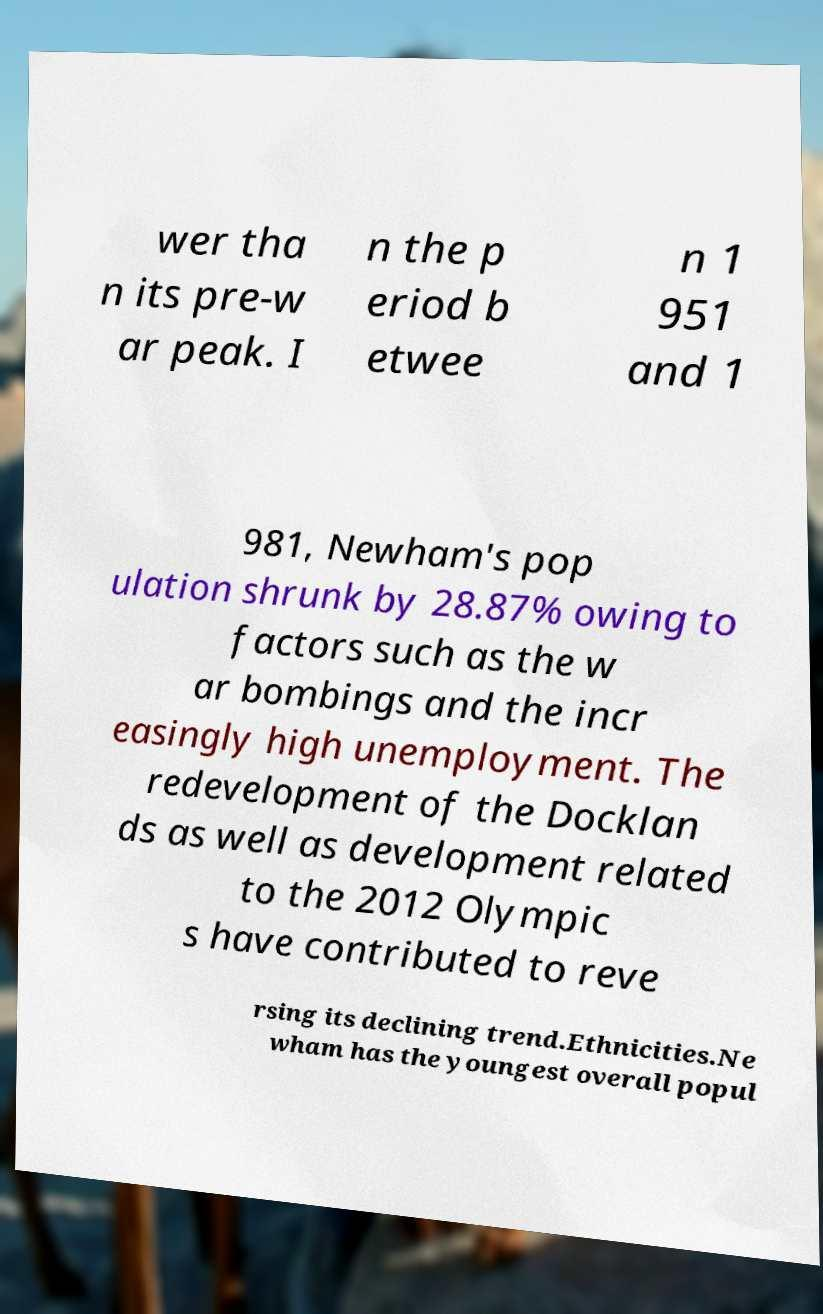For documentation purposes, I need the text within this image transcribed. Could you provide that? wer tha n its pre-w ar peak. I n the p eriod b etwee n 1 951 and 1 981, Newham's pop ulation shrunk by 28.87% owing to factors such as the w ar bombings and the incr easingly high unemployment. The redevelopment of the Docklan ds as well as development related to the 2012 Olympic s have contributed to reve rsing its declining trend.Ethnicities.Ne wham has the youngest overall popul 